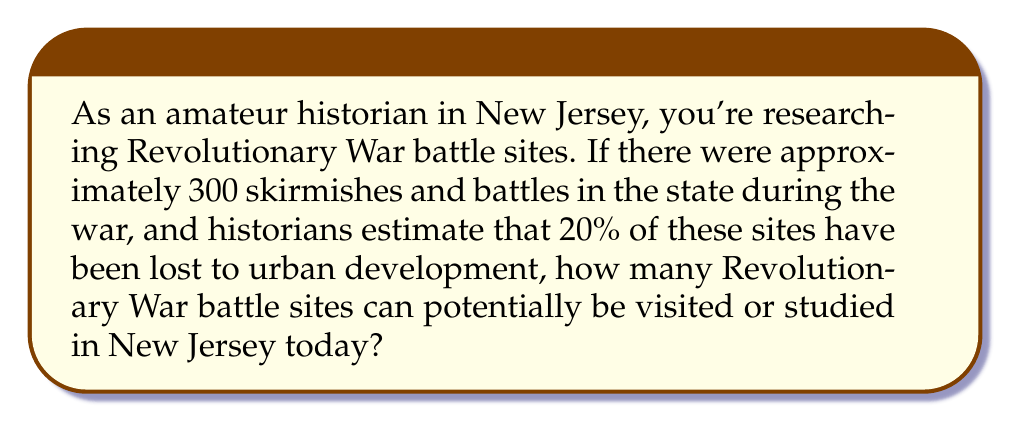Solve this math problem. Let's approach this problem step-by-step:

1. First, we need to identify the total number of battle sites:
   Total battle sites = 300

2. We're told that 20% of these sites have been lost. To calculate the number of remaining sites, we need to subtract this 20% from the total:
   
   Percentage of remaining sites = 100% - 20% = 80%

3. To find the number of remaining sites, we multiply the total number of sites by the percentage of remaining sites:

   $$ \text{Remaining sites} = 300 \times \frac{80}{100} = 300 \times 0.8 $$

4. Calculating this:
   $$ 300 \times 0.8 = 240 $$

Therefore, there are potentially 240 Revolutionary War battle sites that can be visited or studied in New Jersey today.
Answer: 240 sites 